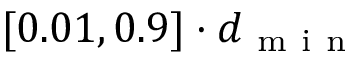<formula> <loc_0><loc_0><loc_500><loc_500>[ 0 . 0 1 , 0 . 9 ] \cdot d _ { m i n }</formula> 